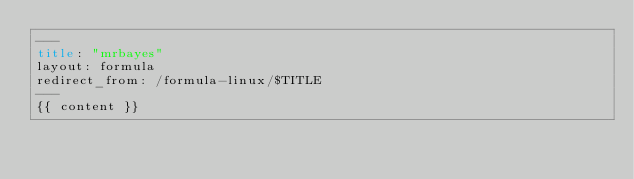Convert code to text. <code><loc_0><loc_0><loc_500><loc_500><_HTML_>---
title: "mrbayes"
layout: formula
redirect_from: /formula-linux/$TITLE
---
{{ content }}
</code> 